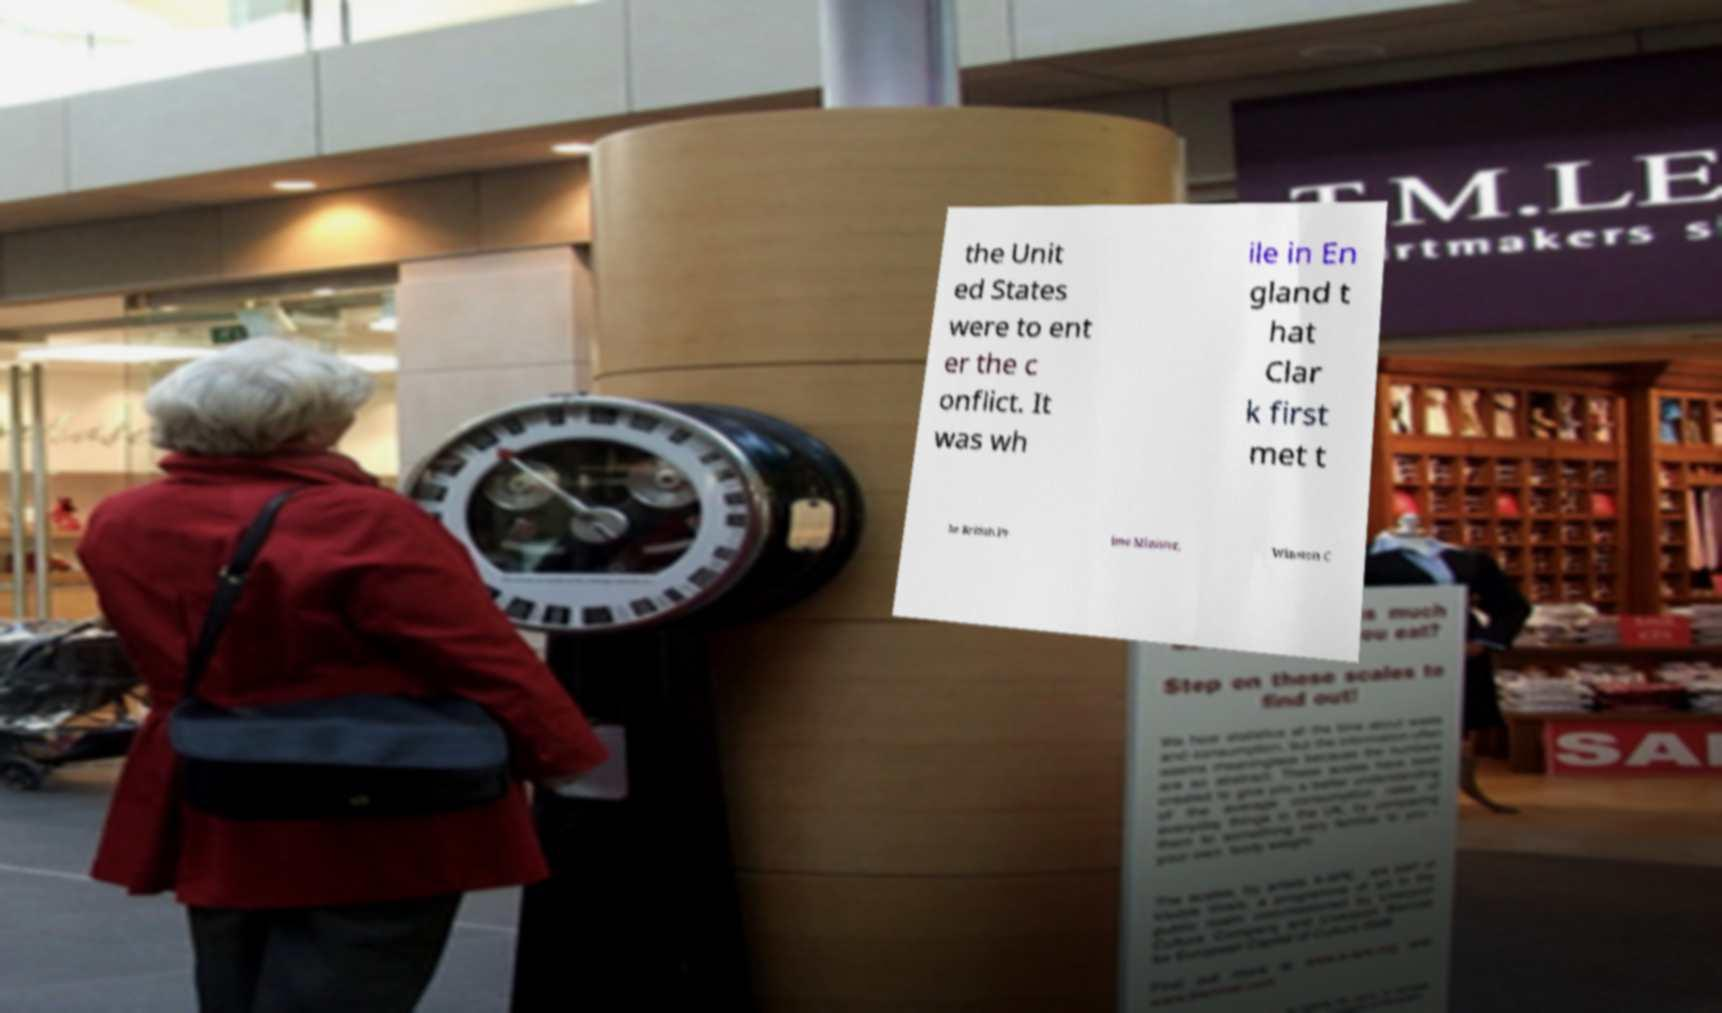What messages or text are displayed in this image? I need them in a readable, typed format. the Unit ed States were to ent er the c onflict. It was wh ile in En gland t hat Clar k first met t he British Pr ime Minister, Winston C 